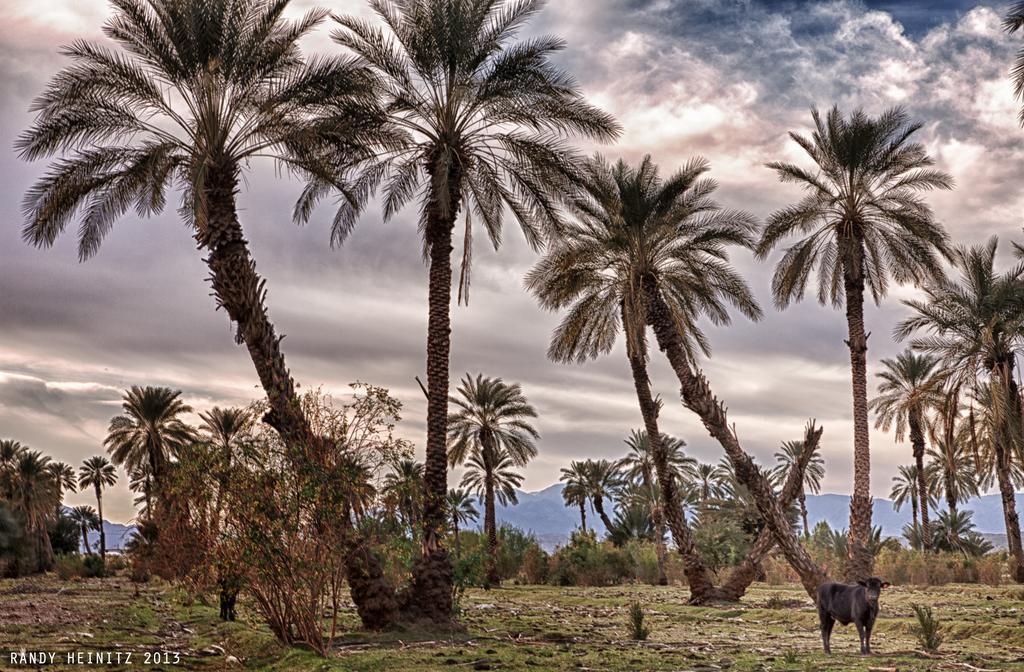Please provide a concise description of this image. In this image we can see an animal, there are plants, trees, also we can see the sky, and the text on the image. 